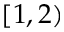<formula> <loc_0><loc_0><loc_500><loc_500>[ 1 , 2 )</formula> 